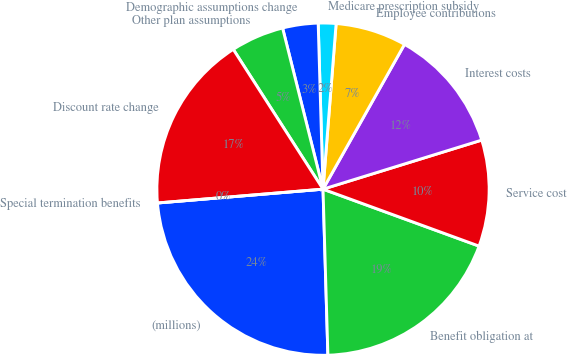Convert chart. <chart><loc_0><loc_0><loc_500><loc_500><pie_chart><fcel>(millions)<fcel>Benefit obligation at<fcel>Service cost<fcel>Interest costs<fcel>Employee contributions<fcel>Medicare prescription subsidy<fcel>Demographic assumptions change<fcel>Other plan assumptions<fcel>Discount rate change<fcel>Special termination benefits<nl><fcel>24.14%<fcel>18.96%<fcel>10.34%<fcel>12.07%<fcel>6.9%<fcel>1.72%<fcel>3.45%<fcel>5.17%<fcel>17.24%<fcel>0.0%<nl></chart> 